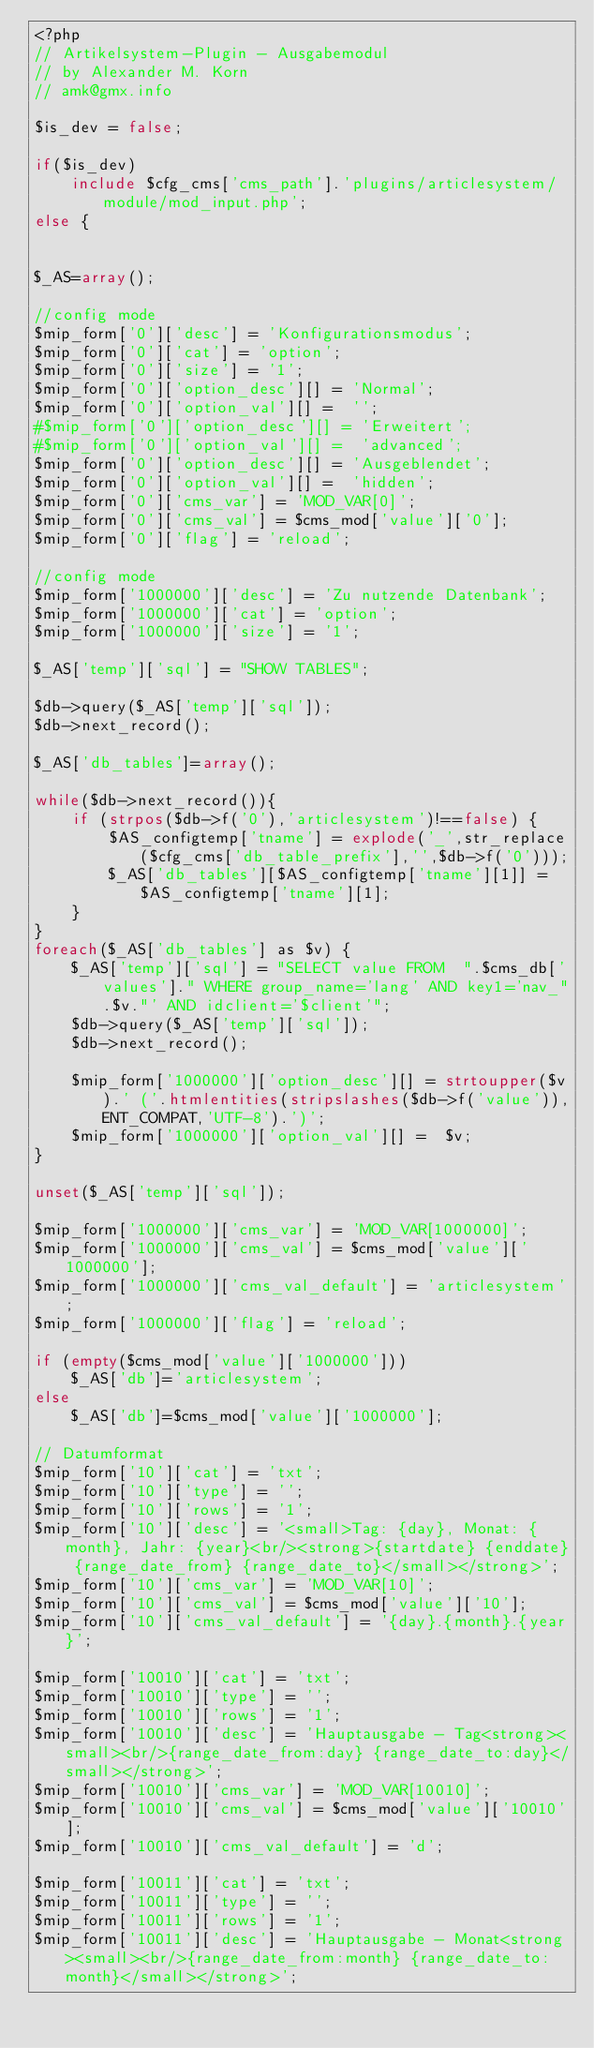<code> <loc_0><loc_0><loc_500><loc_500><_PHP_><?php
// Artikelsystem-Plugin - Ausgabemodul
// by Alexander M. Korn
// amk@gmx.info

$is_dev = false;

if($is_dev)
	include $cfg_cms['cms_path'].'plugins/articlesystem/module/mod_input.php';
else {


$_AS=array();

//config mode
$mip_form['0']['desc'] = 'Konfigurationsmodus';
$mip_form['0']['cat'] = 'option';
$mip_form['0']['size'] = '1';
$mip_form['0']['option_desc'][] = 'Normal';
$mip_form['0']['option_val'][] =  '';
#$mip_form['0']['option_desc'][] = 'Erweitert';
#$mip_form['0']['option_val'][] =  'advanced';
$mip_form['0']['option_desc'][] = 'Ausgeblendet';
$mip_form['0']['option_val'][] =  'hidden';
$mip_form['0']['cms_var'] = 'MOD_VAR[0]';
$mip_form['0']['cms_val'] = $cms_mod['value']['0'];
$mip_form['0']['flag'] = 'reload';

//config mode
$mip_form['1000000']['desc'] = 'Zu nutzende Datenbank';
$mip_form['1000000']['cat'] = 'option';
$mip_form['1000000']['size'] = '1';

$_AS['temp']['sql'] = "SHOW TABLES";

$db->query($_AS['temp']['sql']);
$db->next_record();

$_AS['db_tables']=array();

while($db->next_record()){
	if (strpos($db->f('0'),'articlesystem')!==false) {
		$AS_configtemp['tname'] = explode('_',str_replace($cfg_cms['db_table_prefix'],'',$db->f('0')));
		$_AS['db_tables'][$AS_configtemp['tname'][1]] = $AS_configtemp['tname'][1];
	}
}
foreach($_AS['db_tables'] as $v) {
	$_AS['temp']['sql'] = "SELECT value FROM  ".$cms_db['values']." WHERE group_name='lang' AND key1='nav_".$v."' AND idclient='$client'";
	$db->query($_AS['temp']['sql']);
	$db->next_record();
	
	$mip_form['1000000']['option_desc'][] = strtoupper($v).' ('.htmlentities(stripslashes($db->f('value')),ENT_COMPAT,'UTF-8').')';
	$mip_form['1000000']['option_val'][] =  $v;
}

unset($_AS['temp']['sql']);

$mip_form['1000000']['cms_var'] = 'MOD_VAR[1000000]';
$mip_form['1000000']['cms_val'] = $cms_mod['value']['1000000'];
$mip_form['1000000']['cms_val_default'] = 'articlesystem';
$mip_form['1000000']['flag'] = 'reload';

if (empty($cms_mod['value']['1000000']))
	$_AS['db']='articlesystem';
else
	$_AS['db']=$cms_mod['value']['1000000'];

// Datumformat
$mip_form['10']['cat'] = 'txt';
$mip_form['10']['type'] = '';
$mip_form['10']['rows'] = '1';
$mip_form['10']['desc'] = '<small>Tag: {day}, Monat: {month}, Jahr: {year}<br/><strong>{startdate} {enddate} {range_date_from} {range_date_to}</small></strong>';
$mip_form['10']['cms_var'] = 'MOD_VAR[10]';
$mip_form['10']['cms_val'] = $cms_mod['value']['10'];
$mip_form['10']['cms_val_default'] = '{day}.{month}.{year}';

$mip_form['10010']['cat'] = 'txt';
$mip_form['10010']['type'] = '';
$mip_form['10010']['rows'] = '1';
$mip_form['10010']['desc'] = 'Hauptausgabe - Tag<strong><small><br/>{range_date_from:day} {range_date_to:day}</small></strong>';
$mip_form['10010']['cms_var'] = 'MOD_VAR[10010]';
$mip_form['10010']['cms_val'] = $cms_mod['value']['10010'];
$mip_form['10010']['cms_val_default'] = 'd';

$mip_form['10011']['cat'] = 'txt';
$mip_form['10011']['type'] = '';
$mip_form['10011']['rows'] = '1';
$mip_form['10011']['desc'] = 'Hauptausgabe - Monat<strong><small><br/>{range_date_from:month} {range_date_to:month}</small></strong>';</code> 